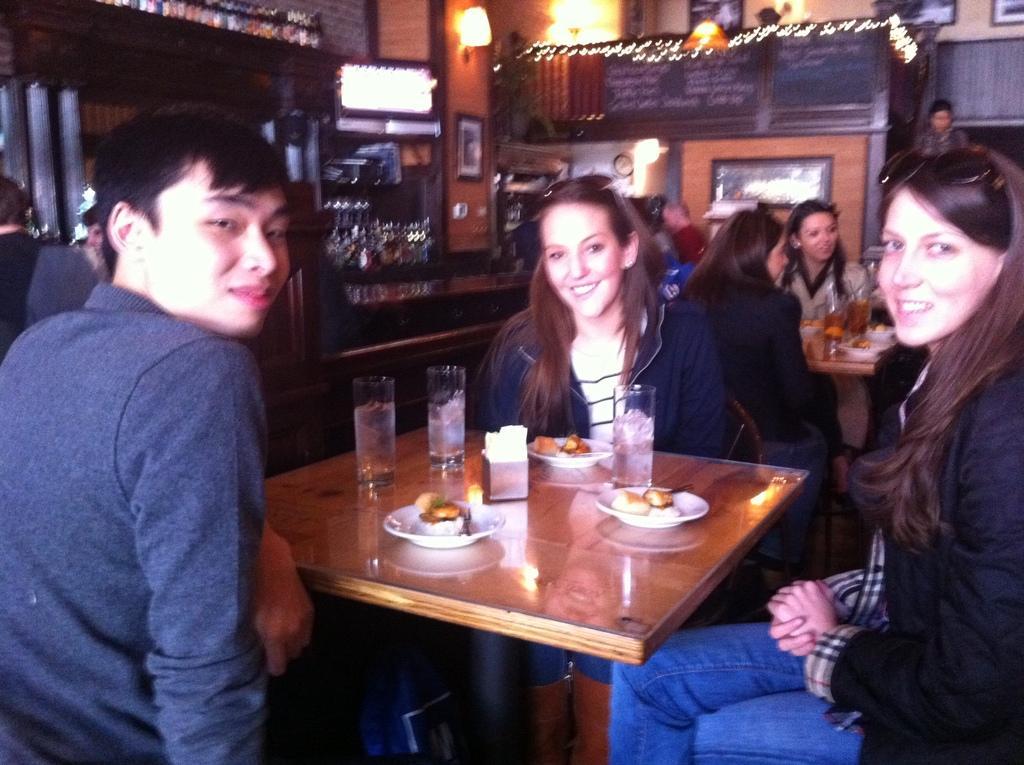Could you give a brief overview of what you see in this image? There are few people sitting on the chair at the table. There is food,tissue paper and glass on the table. Behind them there are lights,screen and wall. 